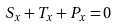<formula> <loc_0><loc_0><loc_500><loc_500>S _ { x } + T _ { x } + P _ { x } = 0</formula> 